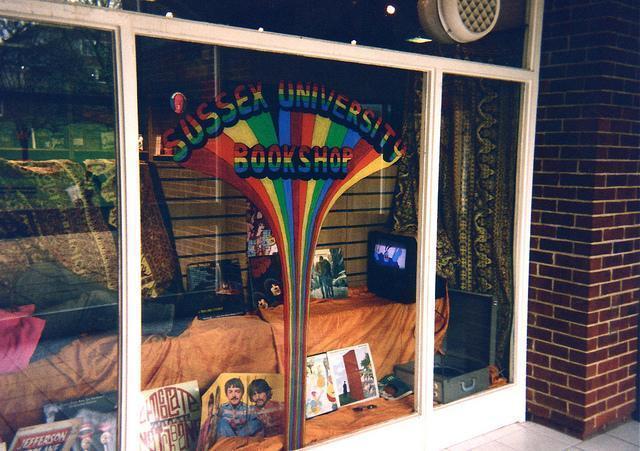What type of clientele does the book store have?
Indicate the correct response and explain using: 'Answer: answer
Rationale: rationale.'
Options: Gay, nazis, jamaicans, african americans. Answer: gay.
Rationale: The type is gay. 